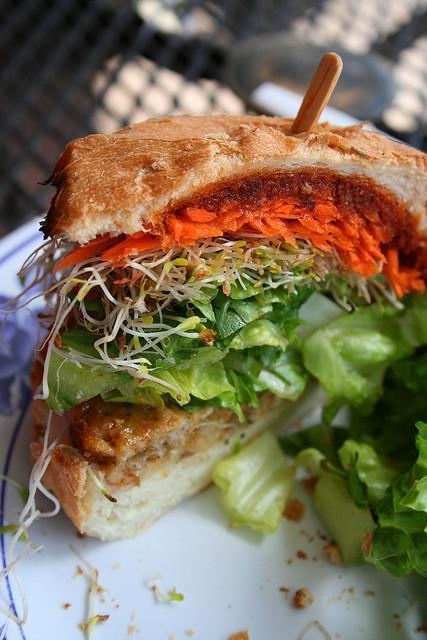Is the given caption "The broccoli is on the sandwich." fitting for the image?
Answer yes or no. No. Evaluate: Does the caption "The broccoli is in the sandwich." match the image?
Answer yes or no. Yes. Is the statement "The sandwich is surrounding the broccoli." accurate regarding the image?
Answer yes or no. No. 